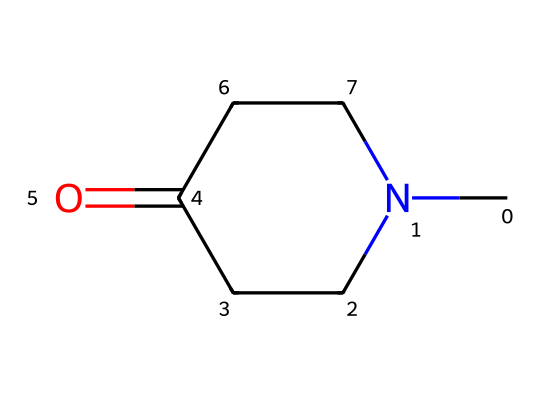What is the molecular formula of N-methylpyrrolidone? The molecular formula can be determined by counting the carbon (C), hydrogen (H), oxygen (O), and nitrogen (N) atoms present in the SMILES notation. The structure CN1CCC(=O)CC1 shows 5 carbon atoms, 9 hydrogen atoms, 1 nitrogen atom, and 1 oxygen atom, which gives the formula C5H9NO.
Answer: C5H9NO How many rings are present in the structure of N-methylpyrrolidone? By analyzing the SMILES representation, the "N1" and "CC1" indicate a cyclic structure where the '1' marks the start and end of a ring. There is one ring present in this chemical.
Answer: 1 What type of functional group is present in N-methylpyrrolidone? The "=O" in the structure indicates the presence of a carbonyl group, specifically associated with an imide. The structure holds the imide functional group which is key to classifying it in that category.
Answer: imide What is the total number of nitrogen atoms in N-methylpyrrolidone? From the SMILES representation, we can identify that "N" appears only once in the structure, indicating the presence of a single nitrogen atom in the molecule.
Answer: 1 What property of N-methylpyrrolidone makes it a suitable solvent in cleaning spacecraft components? The presence of the polar carbonyl group and its ability to dissolve a range of ionic and polar substances make it an effective solvent, allowing it to clean diverse materials on spacecraft without damage.
Answer: solvent properties What is the role of the methyl group in N-methylpyrrolidone? The methyl group contributes to the polarity of the solvent and influences its solubility, enhancing its capability to interact with organic residues while still being somewhat hydrophilic.
Answer: enhances solubility 